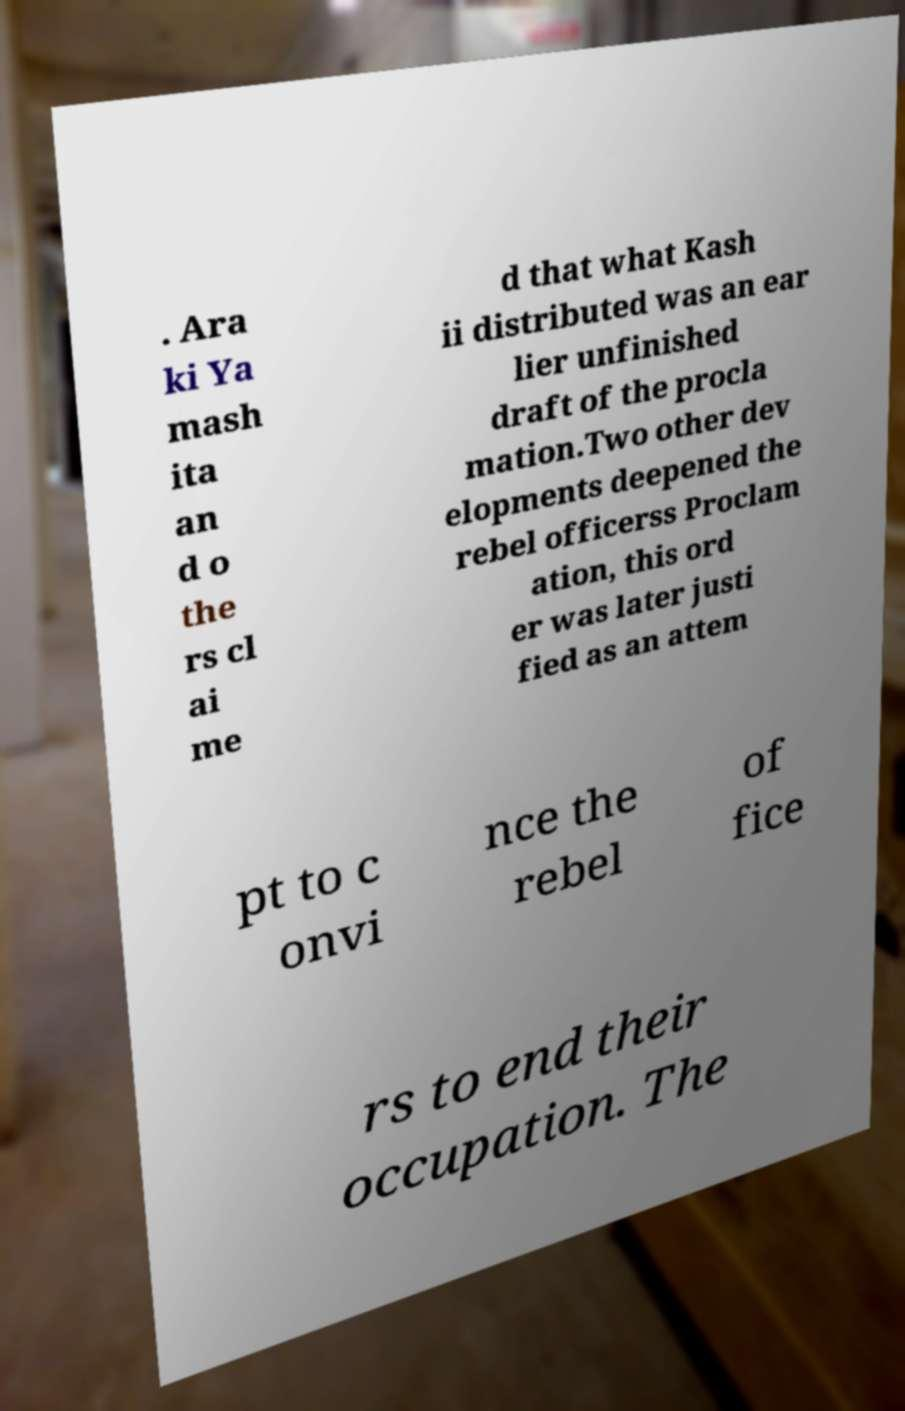Can you accurately transcribe the text from the provided image for me? . Ara ki Ya mash ita an d o the rs cl ai me d that what Kash ii distributed was an ear lier unfinished draft of the procla mation.Two other dev elopments deepened the rebel officerss Proclam ation, this ord er was later justi fied as an attem pt to c onvi nce the rebel of fice rs to end their occupation. The 